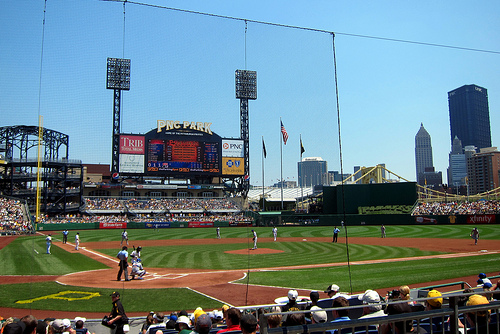<image>
Is the catcher in the ballpark? Yes. The catcher is contained within or inside the ballpark, showing a containment relationship. 